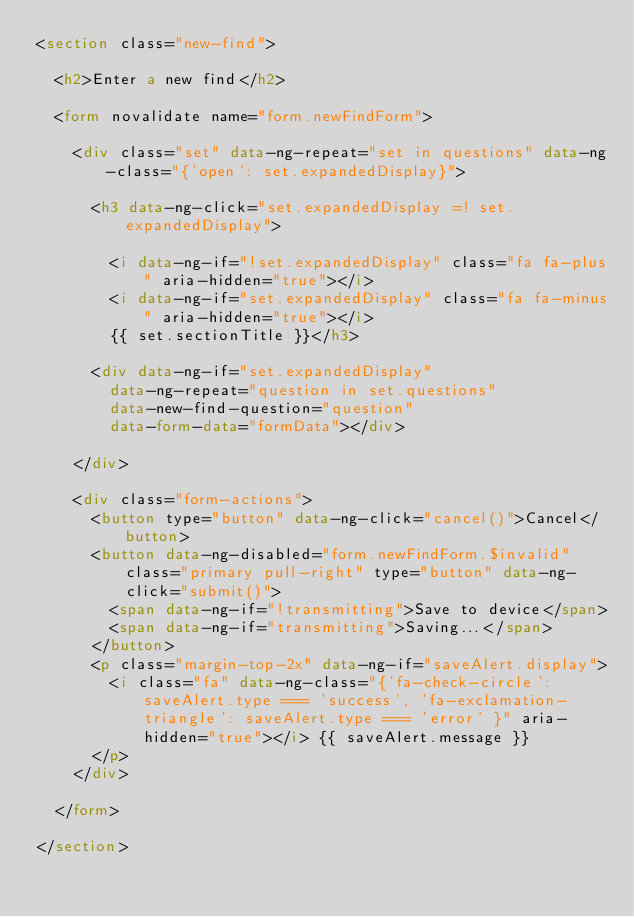<code> <loc_0><loc_0><loc_500><loc_500><_HTML_><section class="new-find">
	
	<h2>Enter a new find</h2>

	<form novalidate name="form.newFindForm">
		
		<div class="set" data-ng-repeat="set in questions" data-ng-class="{'open': set.expandedDisplay}">

			<h3 data-ng-click="set.expandedDisplay =! set.expandedDisplay">

				<i data-ng-if="!set.expandedDisplay" class="fa fa-plus" aria-hidden="true"></i>
				<i data-ng-if="set.expandedDisplay" class="fa fa-minus" aria-hidden="true"></i>
				{{ set.sectionTitle }}</h3>

			<div data-ng-if="set.expandedDisplay"
				data-ng-repeat="question in set.questions"
				data-new-find-question="question"
				data-form-data="formData"></div>

		</div>

		<div class="form-actions">
			<button type="button" data-ng-click="cancel()">Cancel</button>
			<button data-ng-disabled="form.newFindForm.$invalid" class="primary pull-right" type="button" data-ng-click="submit()">
				<span data-ng-if="!transmitting">Save to device</span>
				<span data-ng-if="transmitting">Saving...</span>
			</button>
			<p class="margin-top-2x" data-ng-if="saveAlert.display">
				<i class="fa" data-ng-class="{'fa-check-circle': saveAlert.type === 'success', 'fa-exclamation-triangle': saveAlert.type === 'error' }" aria-hidden="true"></i> {{ saveAlert.message }}
			</p>
		</div>

	</form>

</section></code> 